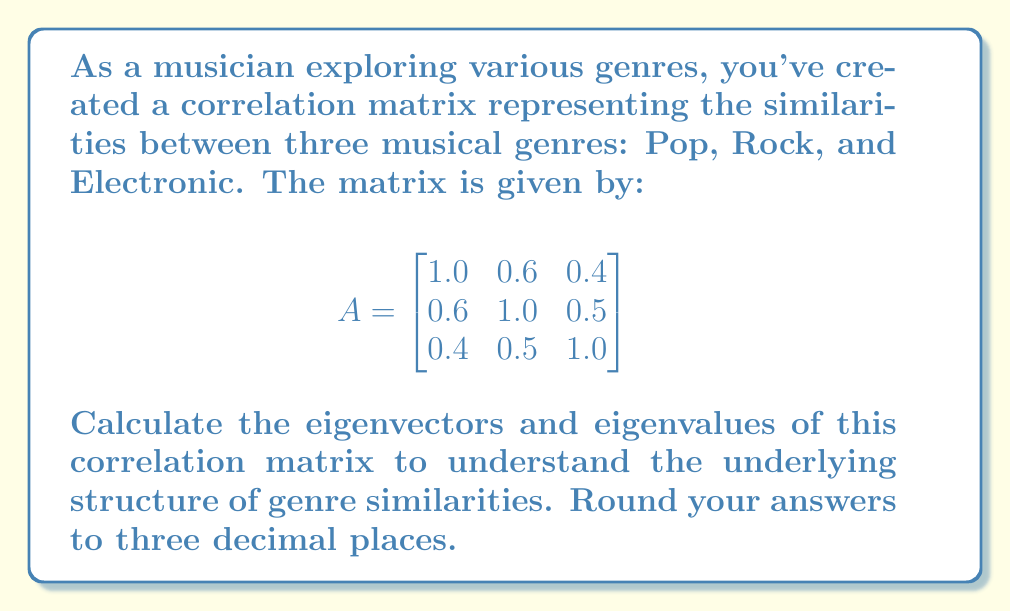Can you answer this question? To find the eigenvectors and eigenvalues of the correlation matrix A, we follow these steps:

1. Find the characteristic equation:
   $det(A - \lambda I) = 0$

2. Expand the determinant:
   $$
   \begin{vmatrix}
   1 - \lambda & 0.6 & 0.4 \\
   0.6 & 1 - \lambda & 0.5 \\
   0.4 & 0.5 & 1 - \lambda
   \end{vmatrix} = 0
   $$

3. Solve the characteristic equation:
   $(1-\lambda)^3 + 0.6 \cdot 0.5 \cdot 0.4 + 0.6 \cdot 0.5 \cdot 0.4 - (1-\lambda)(0.6^2 + 0.4^2 + 0.5^2) = 0$
   
   $-\lambda^3 + 3\lambda^2 - 2.31\lambda + 0.42 = 0$

4. Find the roots of this equation (eigenvalues):
   $\lambda_1 \approx 2.173$
   $\lambda_2 \approx 0.619$
   $\lambda_3 \approx 0.208$

5. For each eigenvalue, solve $(A - \lambda I)v = 0$ to find the corresponding eigenvector:

   For $\lambda_1 \approx 2.173$:
   $$
   \begin{bmatrix}
   -1.173 & 0.6 & 0.4 \\
   0.6 & -1.173 & 0.5 \\
   0.4 & 0.5 & -1.173
   \end{bmatrix}
   \begin{bmatrix}
   v_1 \\ v_2 \\ v_3
   \end{bmatrix} = 
   \begin{bmatrix}
   0 \\ 0 \\ 0
   \end{bmatrix}
   $$
   Solving this system gives $v_1 \approx [0.577, 0.617, 0.535]^T$

   Similarly, for $\lambda_2 \approx 0.619$:
   $v_2 \approx [-0.708, 0.039, 0.705]^T$

   And for $\lambda_3 \approx 0.208$:
   $v_3 \approx [-0.406, 0.786, -0.466]^T$

6. Normalize the eigenvectors to unit length.
Answer: Eigenvalues: $\lambda_1 \approx 2.173$, $\lambda_2 \approx 0.619$, $\lambda_3 \approx 0.208$
Eigenvectors: $v_1 \approx [0.577, 0.617, 0.535]^T$, $v_2 \approx [-0.708, 0.039, 0.705]^T$, $v_3 \approx [-0.406, 0.786, -0.466]^T$ 